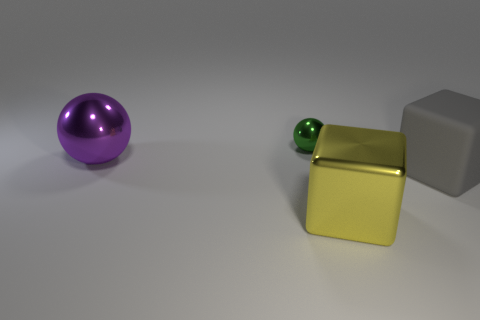Add 2 small green metallic balls. How many objects exist? 6 Add 1 large purple spheres. How many large purple spheres are left? 2 Add 1 large purple shiny balls. How many large purple shiny balls exist? 2 Subtract 0 blue balls. How many objects are left? 4 Subtract all brown spheres. Subtract all cyan cylinders. How many spheres are left? 2 Subtract all yellow metal spheres. Subtract all large yellow shiny cubes. How many objects are left? 3 